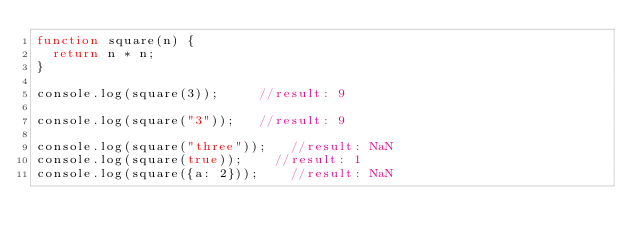Convert code to text. <code><loc_0><loc_0><loc_500><loc_500><_JavaScript_>function square(n) {
  return n * n;
}

console.log(square(3));			//result: 9

console.log(square("3"));		//result: 9

console.log(square("three"));		//result: NaN
console.log(square(true));		//result: 1
console.log(square({a: 2}));		//result: NaN</code> 